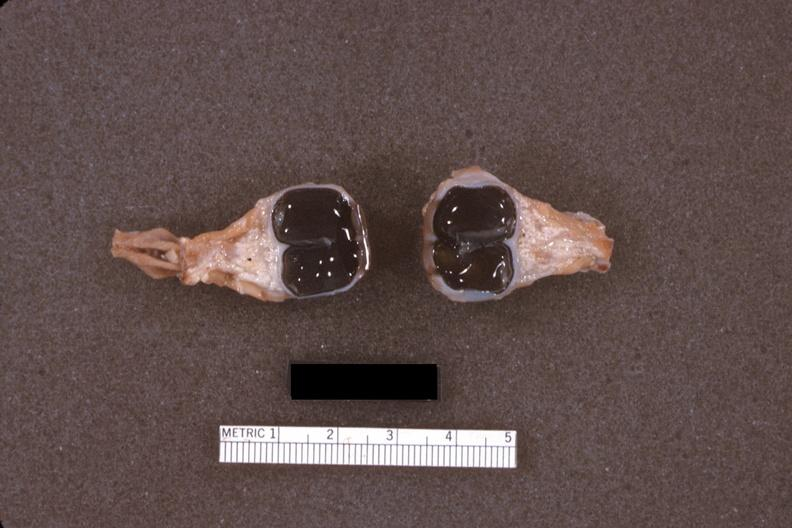what dissected eyes?
Answer the question using a single word or phrase. Fixed tissue 